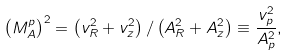<formula> <loc_0><loc_0><loc_500><loc_500>\left ( M _ { A } ^ { p } \right ) ^ { 2 } = \left ( v _ { R } ^ { 2 } + v _ { z } ^ { 2 } \right ) / \left ( A _ { R } ^ { 2 } + A _ { z } ^ { 2 } \right ) \equiv \frac { v _ { p } ^ { 2 } } { A _ { p } ^ { 2 } } ,</formula> 